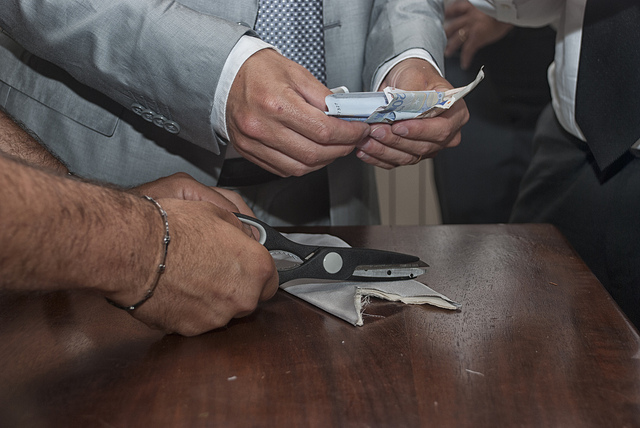<image>What are they making? I don't know what they are making. It could be origami, cloth, money, fabric cuts, ties, paper squares, garments, or crafts. What are they making? I am not sure what they are making. It can be origami, cloth, money or crafts. 